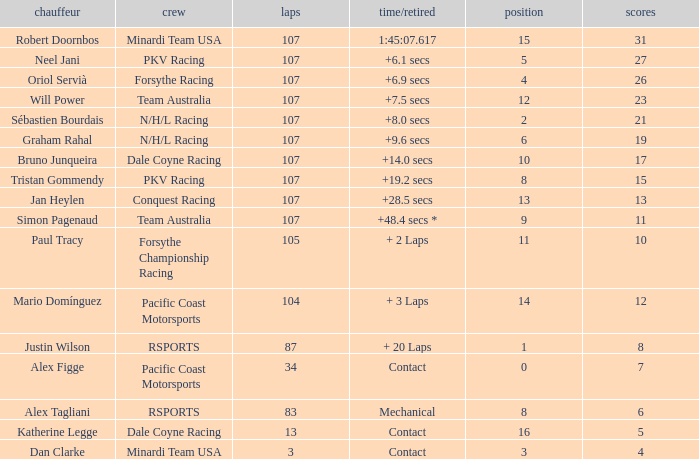What is mario domínguez's average Grid? 14.0. 